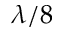<formula> <loc_0><loc_0><loc_500><loc_500>\lambda / 8</formula> 